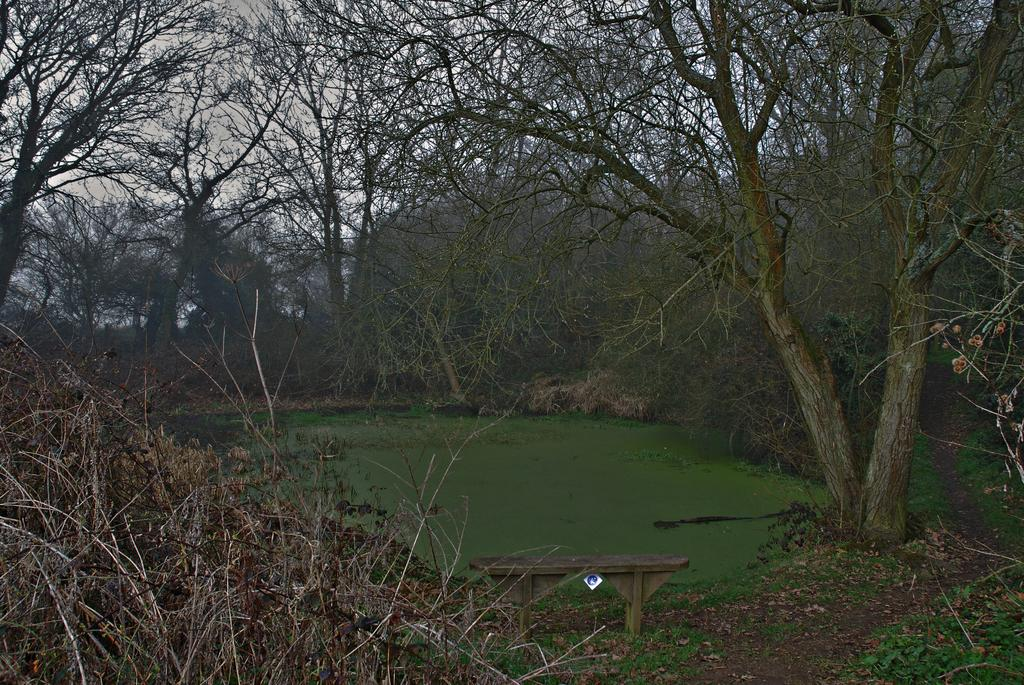What type of vegetation is present in the image? There are trees with branches and leaves in the image. What type of seating is available in the image? There is a wooden bench in the image. What is the condition of the water in the pond? The water in the pond has green algae on it. What type of grain is being harvested in the image? There is no grain present in the image; it features trees, a wooden bench, and a pond with green algae. 